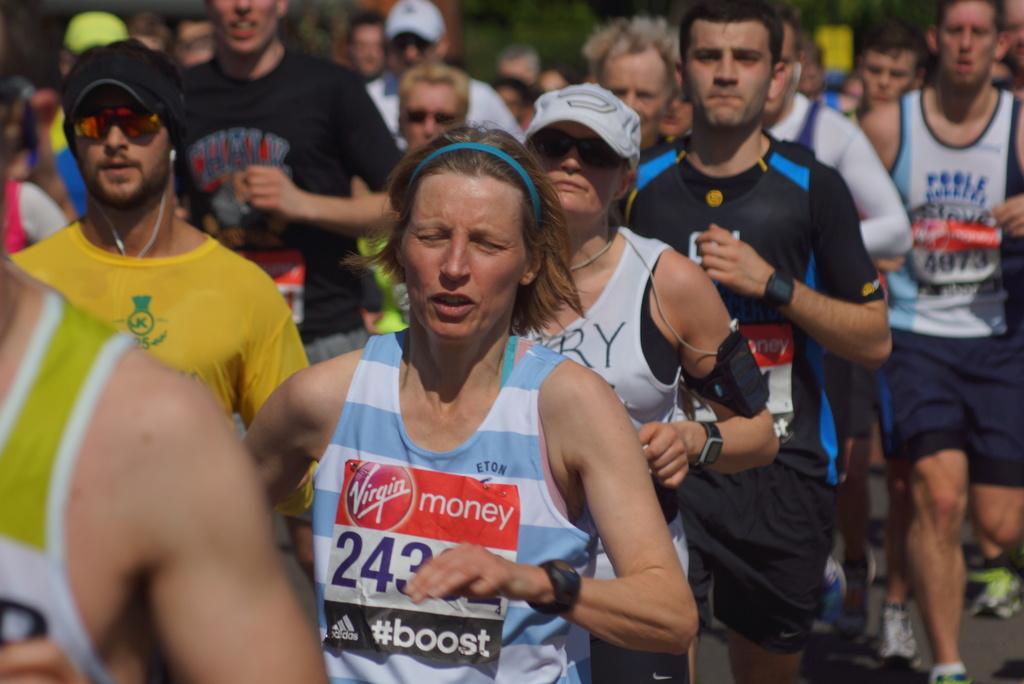Describe this image in one or two sentences. In this picture we can see a group of people running on the road. Behind the people there is the blurred background. 